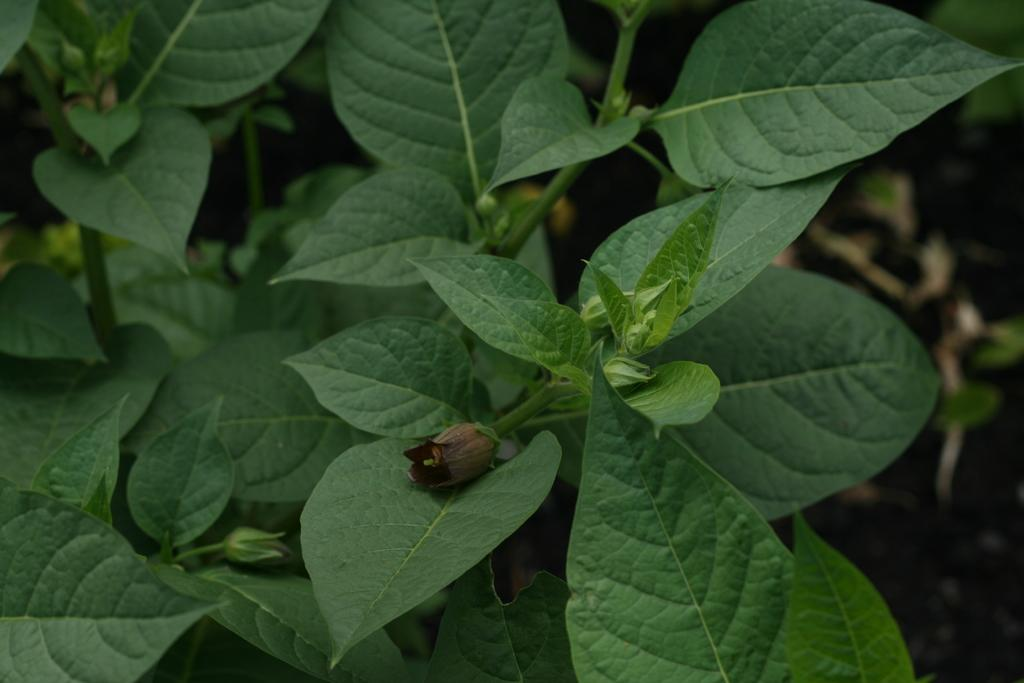What type of living organisms can be seen in the image? Plants and a flower are visible in the image. Can you describe the flower in the image? The flower is a part of the plant in the image. What type of support can be seen in the image? There is no support visible in the image; it only features plants and a flower. 